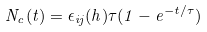Convert formula to latex. <formula><loc_0><loc_0><loc_500><loc_500>N _ { c } ( t ) = \epsilon _ { i j } ( h ) \tau ( 1 - e ^ { - t / \tau } )</formula> 